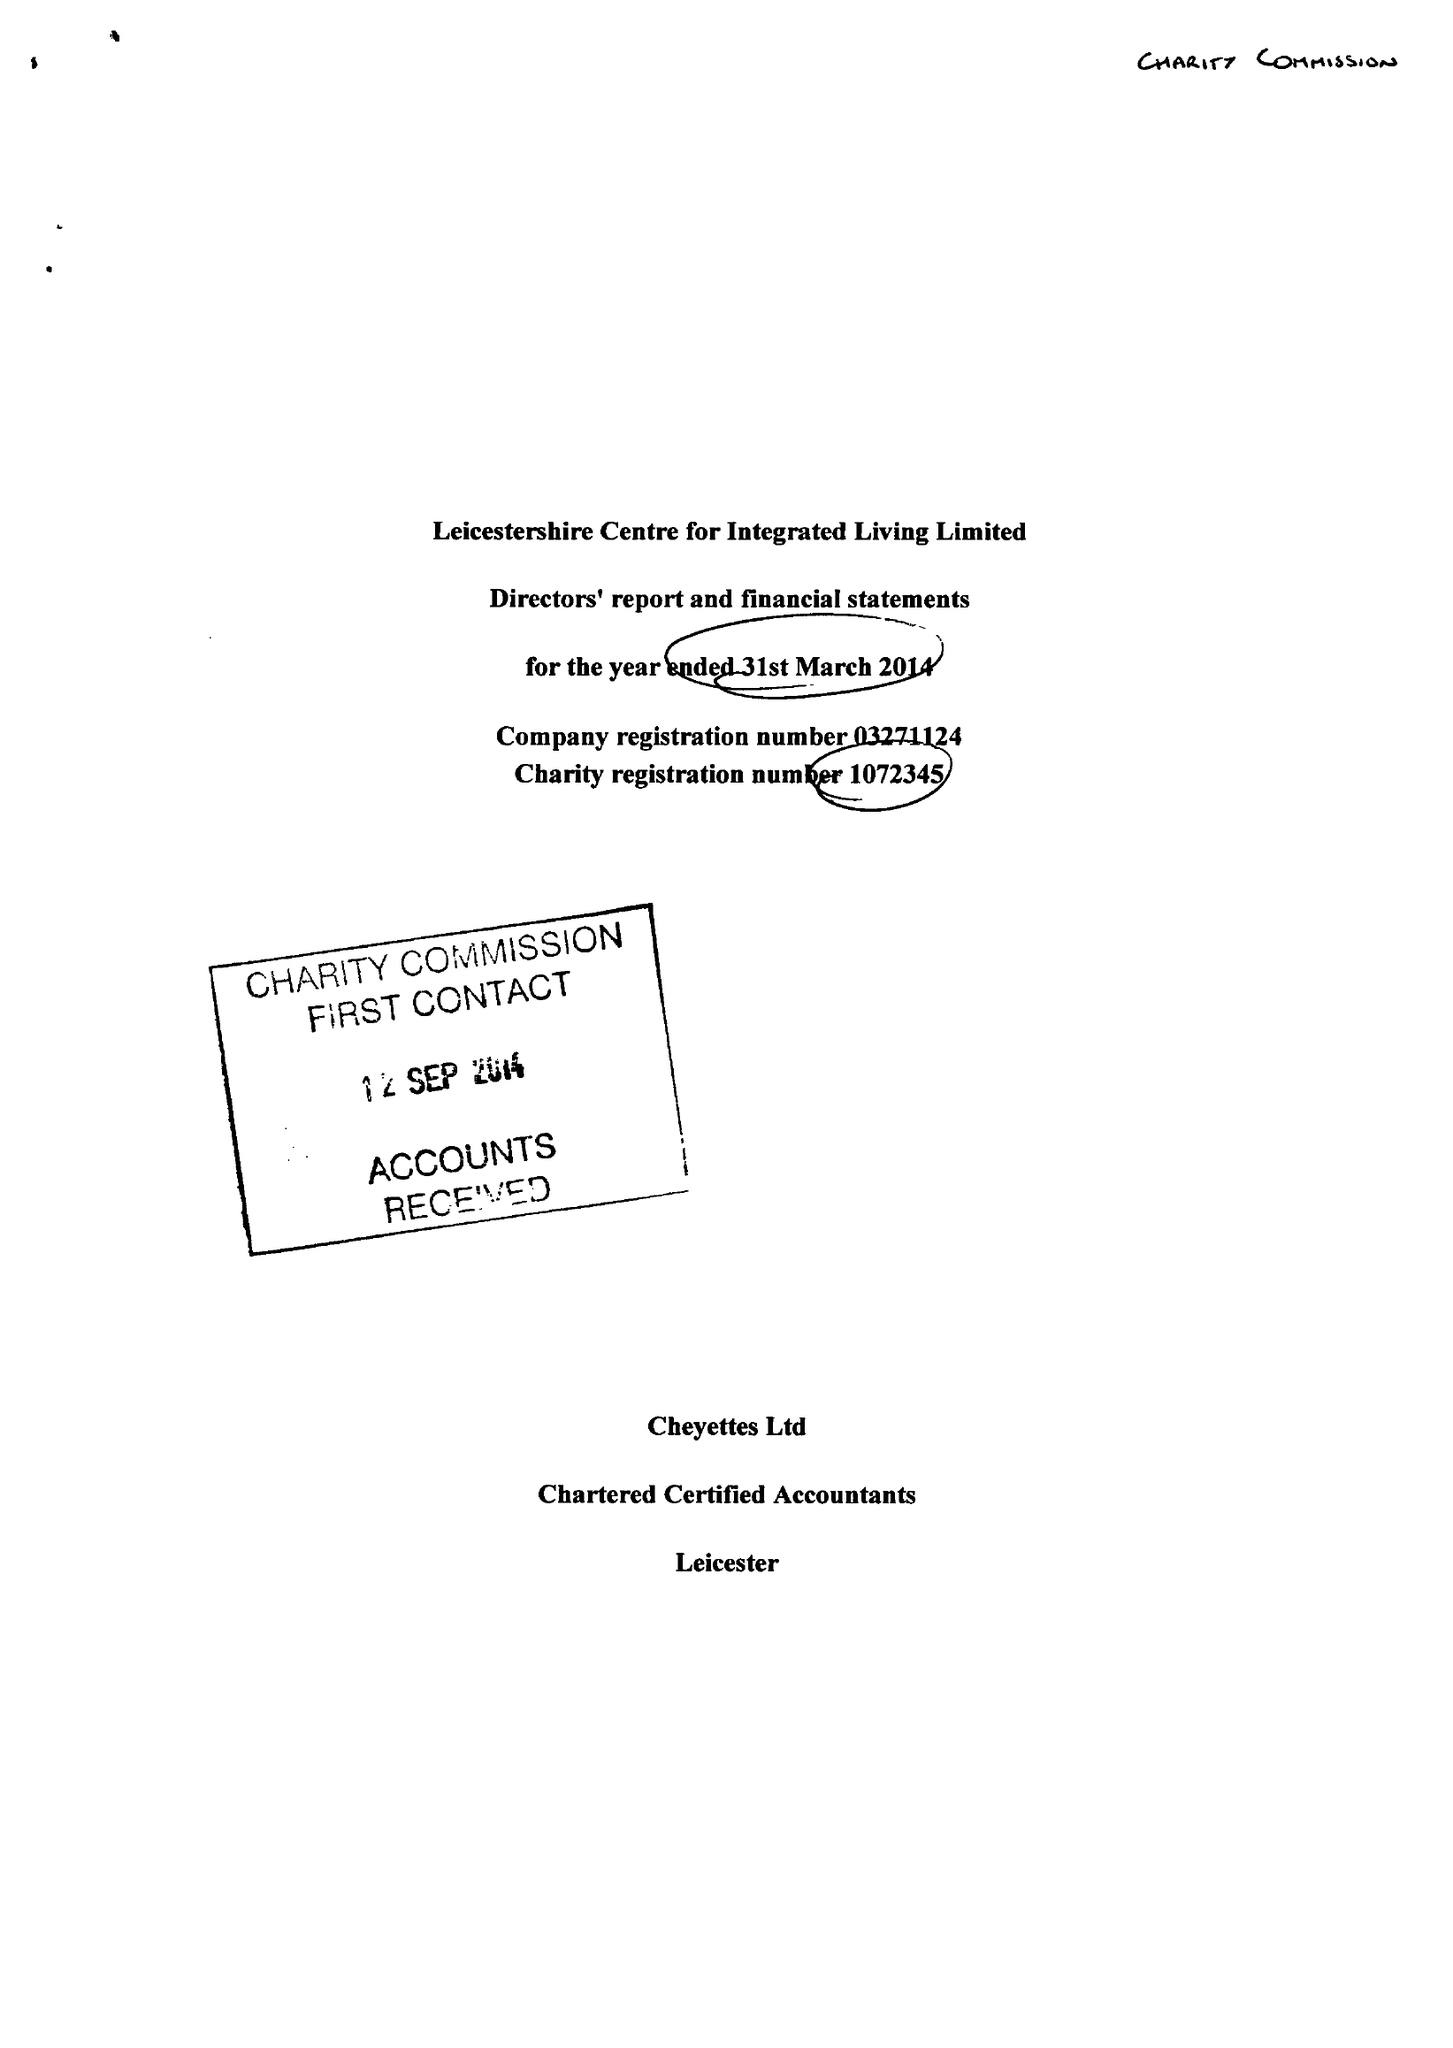What is the value for the charity_number?
Answer the question using a single word or phrase. 1072345 